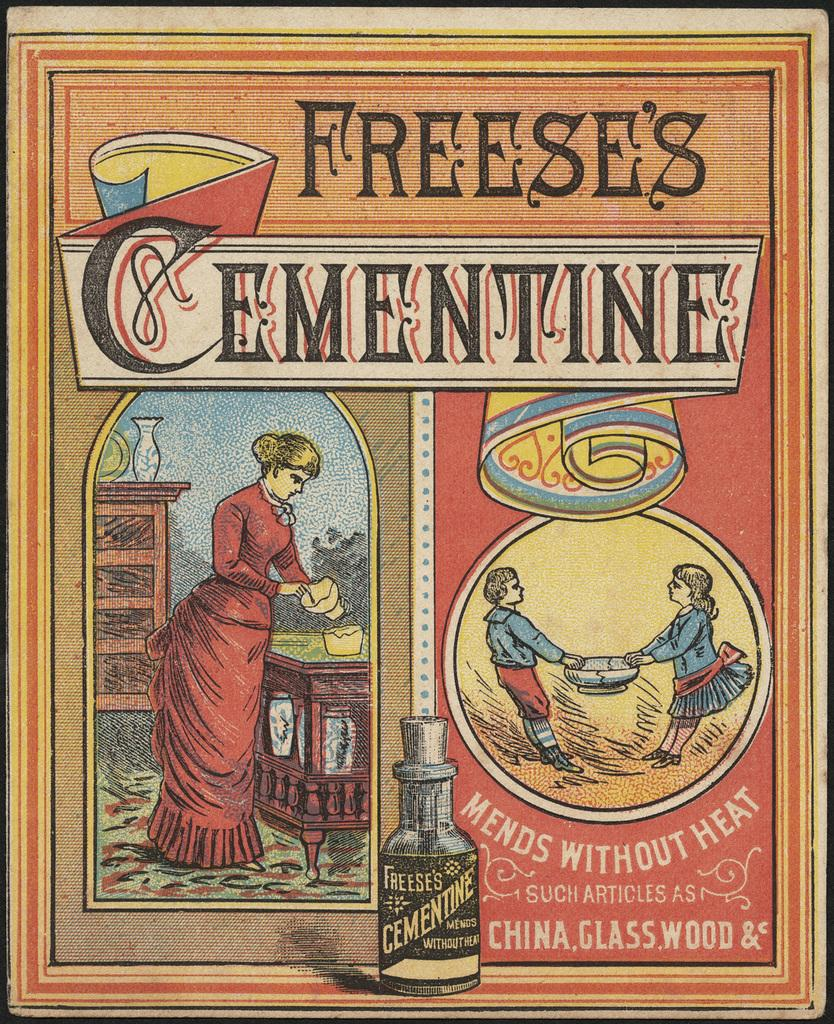What is featured on the poster in the image? There is a poster in the image that contains text, a woman, two kids, and a bottle. Can you describe the text on the poster? Unfortunately, the specific text on the poster cannot be determined from the image. What is the woman doing on the poster? The image does not provide enough detail to determine what the woman is doing on the poster. What is the relationship between the two kids on the poster? The image does not provide enough detail to determine the relationship between the two kids on the poster. What type of marble is being used as a prop in the poster? There is no marble present in the image or on the poster. What invention is being advertised on the poster? The image does not provide enough detail to determine if an invention is being advertised on the poster. 